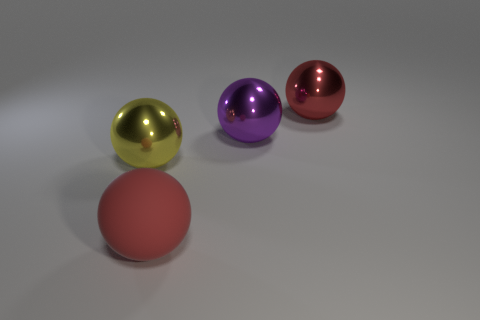There is a large metallic thing that is the same color as the large rubber thing; what is its shape?
Offer a very short reply. Sphere. There is a large red thing right of the big red rubber ball; is its shape the same as the large red object that is in front of the purple thing?
Provide a short and direct response. Yes. There is a yellow thing that is the same shape as the red matte object; what material is it?
Make the answer very short. Metal. What number of cubes are either purple things or rubber objects?
Offer a terse response. 0. How many things have the same material as the big purple sphere?
Your response must be concise. 2. Do the big red thing that is to the right of the big red rubber sphere and the ball to the left of the matte ball have the same material?
Give a very brief answer. Yes. How many big purple spheres are on the right side of the big red ball on the left side of the ball behind the big purple object?
Offer a terse response. 1. Do the metal ball that is on the left side of the red matte ball and the large metal ball that is right of the large purple metallic thing have the same color?
Give a very brief answer. No. Are there any other things that are the same color as the big rubber sphere?
Your answer should be very brief. Yes. What is the color of the big thing in front of the object to the left of the matte ball?
Keep it short and to the point. Red. 